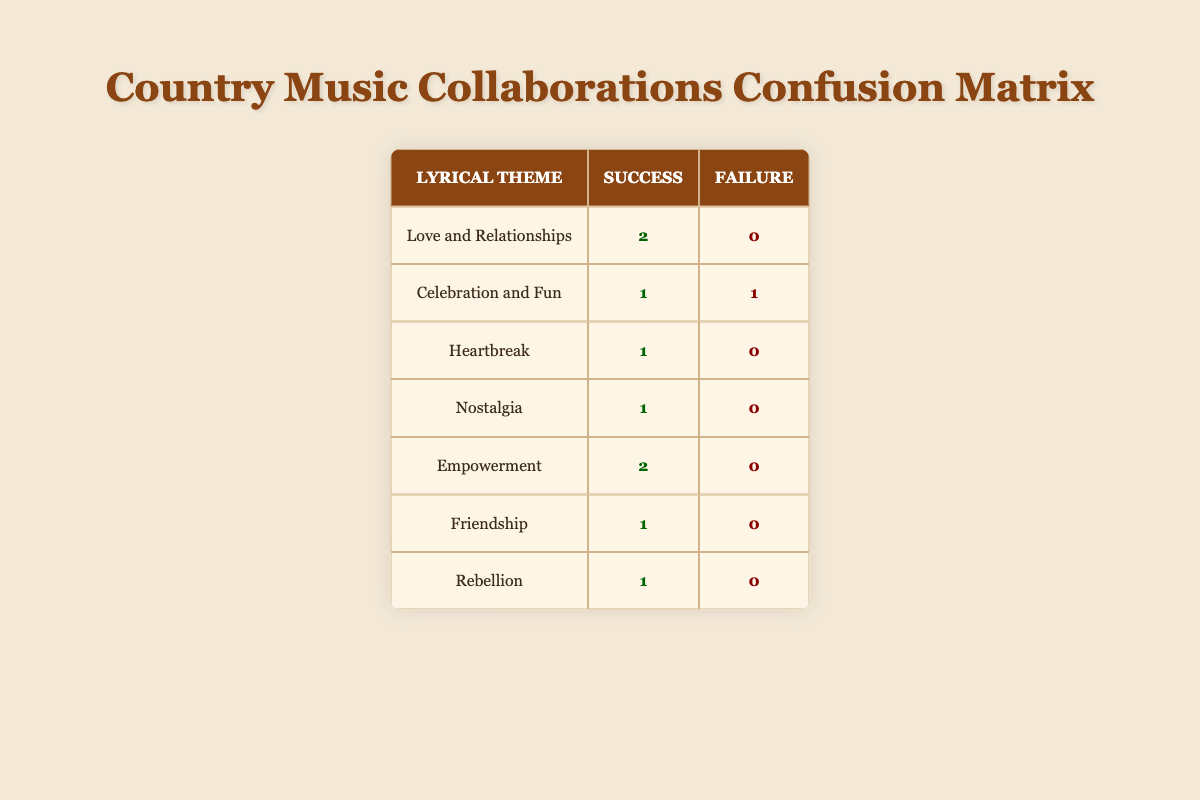What is the total number of successful collaborations in the category of Love and Relationships? In the table, there are two successful collaborations under the lyrical theme "Love and Relationships." By looking specifically at the row for this theme, it shows a total of 2 successful collaborations.
Answer: 2 How many lyrical themes have a failure rate of 0? To find this, we can look at each lyrical theme's success and failure counts. Themes such as "Love and Relationships," "Heartbreak," "Nostalgia," "Empowerment," "Friendship," and "Rebellion" all have 0 failures ([0]). Counting these themes, we find that there are 6 with no failures.
Answer: 6 Is it true that every collaboration based on the lyrical theme of Empowerment was successful? By checking the row for "Empowerment," we see that it lists 2 successful collaborations and 0 failures. This confirms that every collaboration in this category was indeed successful.
Answer: Yes Which lyrical theme has the highest number of collaborations, and how many of them were successful? Here we examine the categories with more than one entry. "Love and Relationships" has 2 successful collaborations and no failures, while "Celebration and Fun" has 1 successful collaboration and 1 failure. Thus, "Love and Relationships" has the most with 2 successful collaborations.
Answer: Love and Relationships; 2 What is the total number of collaborations that resulted in success across all lyrical themes? We look at the table and sum the successful collaborations, which are: 2 (Love and Relationships) + 1 (Celebration and Fun) + 1 (Heartbreak) + 1 (Nostalgia) + 2 (Empowerment) + 1 (Friendship) + 1 (Rebellion) = 9 successful collaborations in total.
Answer: 9 